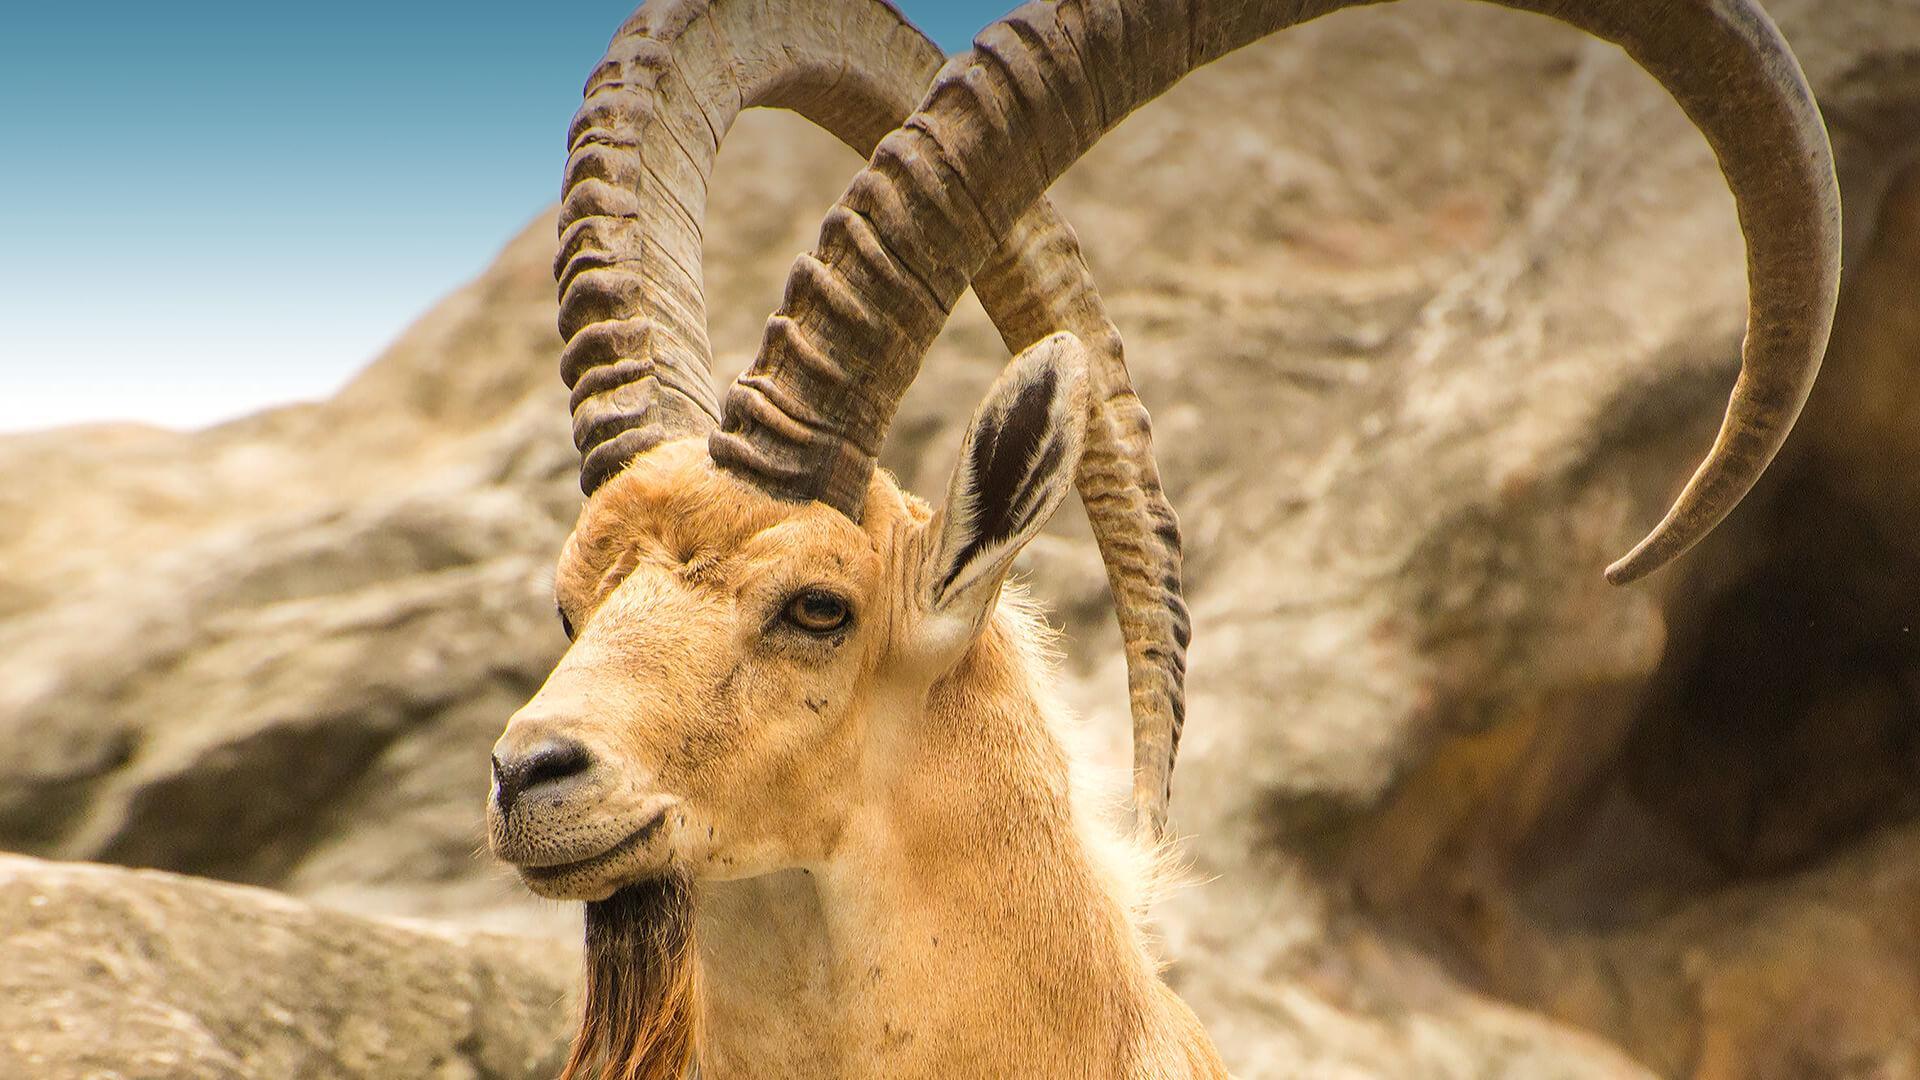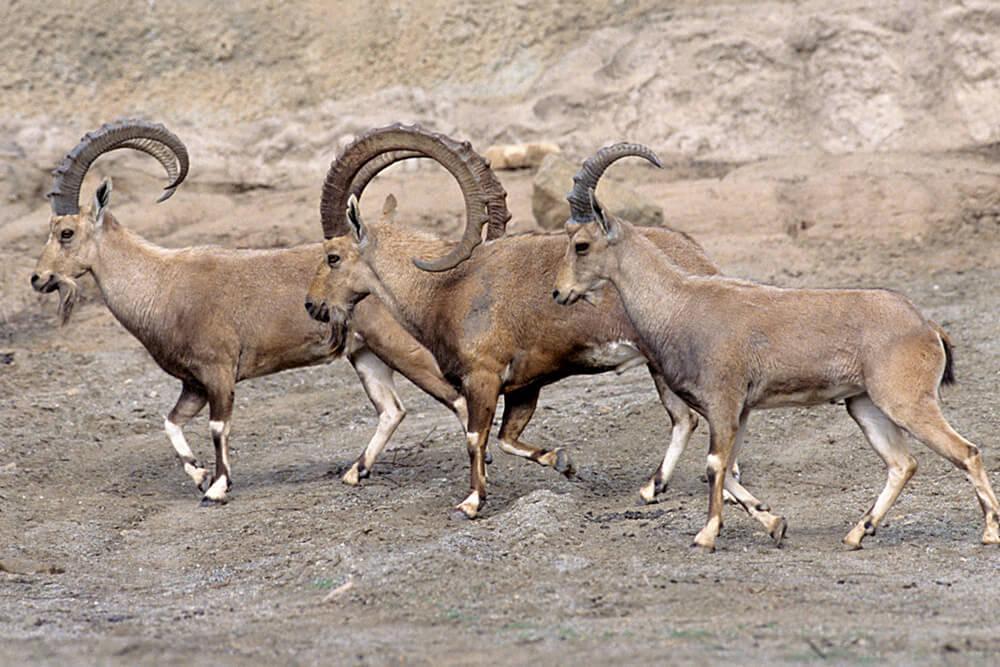The first image is the image on the left, the second image is the image on the right. Given the left and right images, does the statement "One animal is laying down." hold true? Answer yes or no. No. 